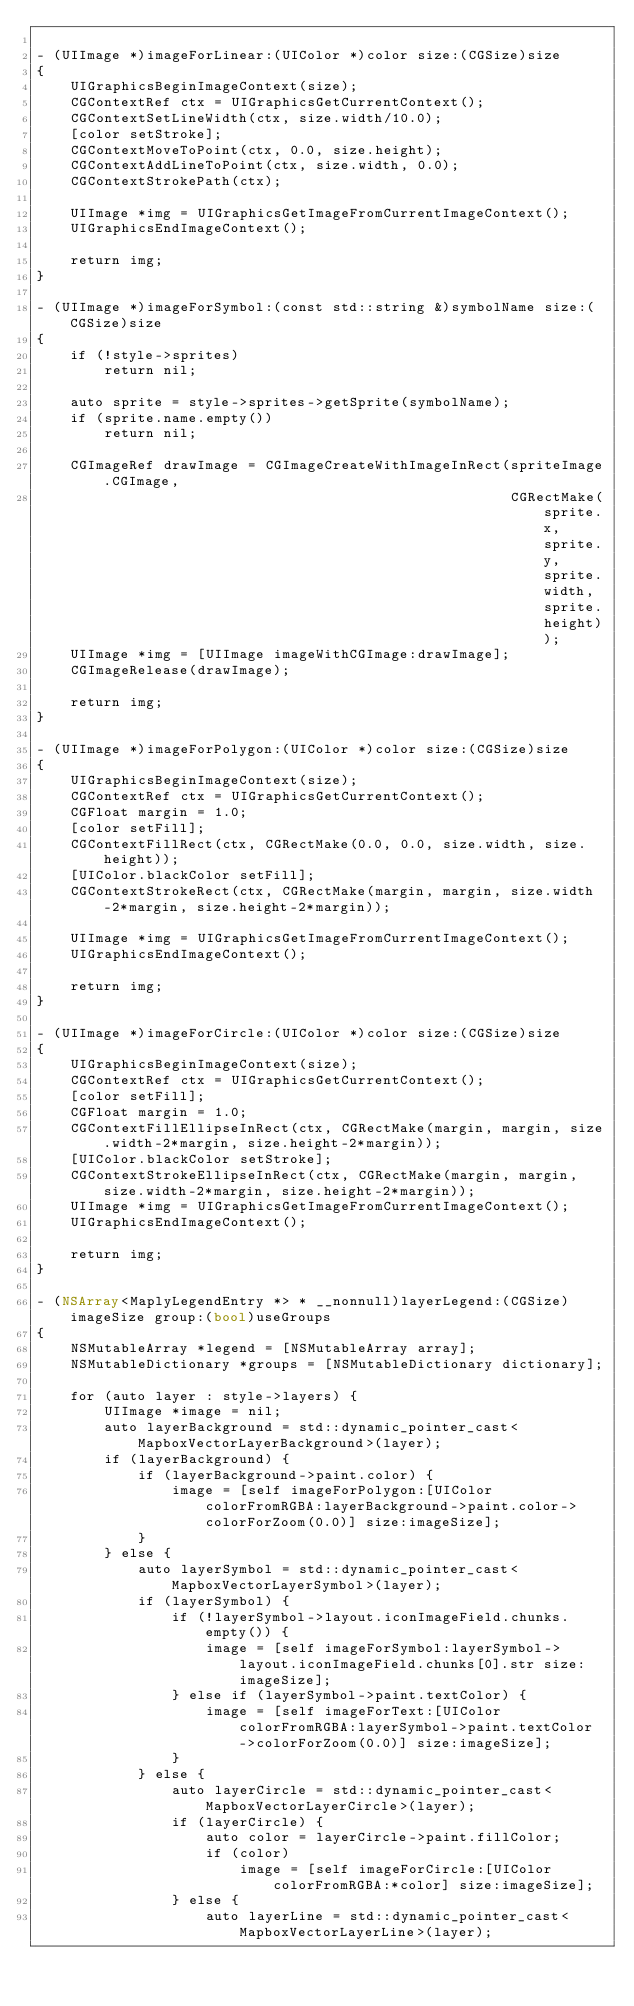<code> <loc_0><loc_0><loc_500><loc_500><_ObjectiveC_>
- (UIImage *)imageForLinear:(UIColor *)color size:(CGSize)size
{
    UIGraphicsBeginImageContext(size);
    CGContextRef ctx = UIGraphicsGetCurrentContext();
    CGContextSetLineWidth(ctx, size.width/10.0);
    [color setStroke];
    CGContextMoveToPoint(ctx, 0.0, size.height);
    CGContextAddLineToPoint(ctx, size.width, 0.0);
    CGContextStrokePath(ctx);
    
    UIImage *img = UIGraphicsGetImageFromCurrentImageContext();
    UIGraphicsEndImageContext();

    return img;
}

- (UIImage *)imageForSymbol:(const std::string &)symbolName size:(CGSize)size
{
    if (!style->sprites)
        return nil;
    
    auto sprite = style->sprites->getSprite(symbolName);
    if (sprite.name.empty())
        return nil;

    CGImageRef drawImage = CGImageCreateWithImageInRect(spriteImage.CGImage,
                                                        CGRectMake(sprite.x, sprite.y, sprite.width, sprite.height));
    UIImage *img = [UIImage imageWithCGImage:drawImage];
    CGImageRelease(drawImage);

    return img;
}

- (UIImage *)imageForPolygon:(UIColor *)color size:(CGSize)size
{
    UIGraphicsBeginImageContext(size);
    CGContextRef ctx = UIGraphicsGetCurrentContext();
    CGFloat margin = 1.0;
    [color setFill];
    CGContextFillRect(ctx, CGRectMake(0.0, 0.0, size.width, size.height));
    [UIColor.blackColor setFill];
    CGContextStrokeRect(ctx, CGRectMake(margin, margin, size.width-2*margin, size.height-2*margin));

    UIImage *img = UIGraphicsGetImageFromCurrentImageContext();
    UIGraphicsEndImageContext();

    return img;
}

- (UIImage *)imageForCircle:(UIColor *)color size:(CGSize)size
{
    UIGraphicsBeginImageContext(size);
    CGContextRef ctx = UIGraphicsGetCurrentContext();
    [color setFill];
    CGFloat margin = 1.0;
    CGContextFillEllipseInRect(ctx, CGRectMake(margin, margin, size.width-2*margin, size.height-2*margin));
    [UIColor.blackColor setStroke];
    CGContextStrokeEllipseInRect(ctx, CGRectMake(margin, margin, size.width-2*margin, size.height-2*margin));
    UIImage *img = UIGraphicsGetImageFromCurrentImageContext();
    UIGraphicsEndImageContext();

    return img;
}

- (NSArray<MaplyLegendEntry *> * __nonnull)layerLegend:(CGSize)imageSize group:(bool)useGroups
{
    NSMutableArray *legend = [NSMutableArray array];
    NSMutableDictionary *groups = [NSMutableDictionary dictionary];
    
    for (auto layer : style->layers) {
        UIImage *image = nil;
        auto layerBackground = std::dynamic_pointer_cast<MapboxVectorLayerBackground>(layer);
        if (layerBackground) {
            if (layerBackground->paint.color) {
                image = [self imageForPolygon:[UIColor colorFromRGBA:layerBackground->paint.color->colorForZoom(0.0)] size:imageSize];
            }
        } else {
            auto layerSymbol = std::dynamic_pointer_cast<MapboxVectorLayerSymbol>(layer);
            if (layerSymbol) {
                if (!layerSymbol->layout.iconImageField.chunks.empty()) {
                    image = [self imageForSymbol:layerSymbol->layout.iconImageField.chunks[0].str size:imageSize];
                } else if (layerSymbol->paint.textColor) {
                    image = [self imageForText:[UIColor colorFromRGBA:layerSymbol->paint.textColor->colorForZoom(0.0)] size:imageSize];
                }
            } else {
                auto layerCircle = std::dynamic_pointer_cast<MapboxVectorLayerCircle>(layer);
                if (layerCircle) {
                    auto color = layerCircle->paint.fillColor;
                    if (color)
                        image = [self imageForCircle:[UIColor colorFromRGBA:*color] size:imageSize];
                } else {
                    auto layerLine = std::dynamic_pointer_cast<MapboxVectorLayerLine>(layer);</code> 